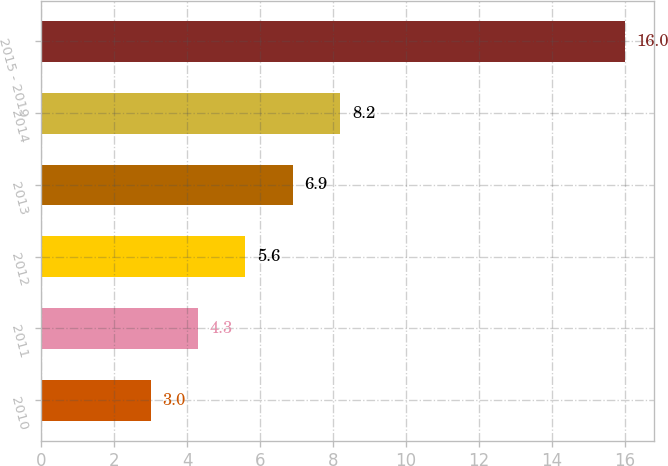Convert chart. <chart><loc_0><loc_0><loc_500><loc_500><bar_chart><fcel>2010<fcel>2011<fcel>2012<fcel>2013<fcel>2014<fcel>2015 - 2019<nl><fcel>3<fcel>4.3<fcel>5.6<fcel>6.9<fcel>8.2<fcel>16<nl></chart> 